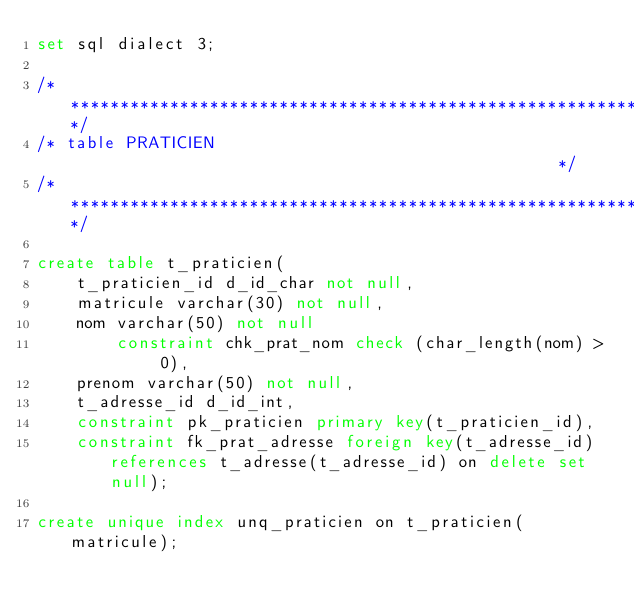Convert code to text. <code><loc_0><loc_0><loc_500><loc_500><_SQL_>set sql dialect 3;

/********************************************************************/
/* table PRATICIEN                                                  */
/********************************************************************/

create table t_praticien(
    t_praticien_id d_id_char not null,
    matricule varchar(30) not null,
    nom varchar(50) not null            
        constraint chk_prat_nom check (char_length(nom) > 0),
    prenom varchar(50) not null,
    t_adresse_id d_id_int,
    constraint pk_praticien primary key(t_praticien_id),
    constraint fk_prat_adresse foreign key(t_adresse_id) references t_adresse(t_adresse_id) on delete set null);

create unique index unq_praticien on t_praticien(matricule);
</code> 